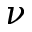Convert formula to latex. <formula><loc_0><loc_0><loc_500><loc_500>\nu</formula> 